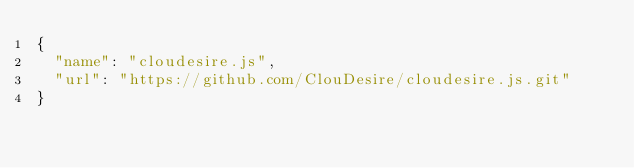<code> <loc_0><loc_0><loc_500><loc_500><_JavaScript_>{
  "name": "cloudesire.js",
  "url": "https://github.com/ClouDesire/cloudesire.js.git"
}
</code> 